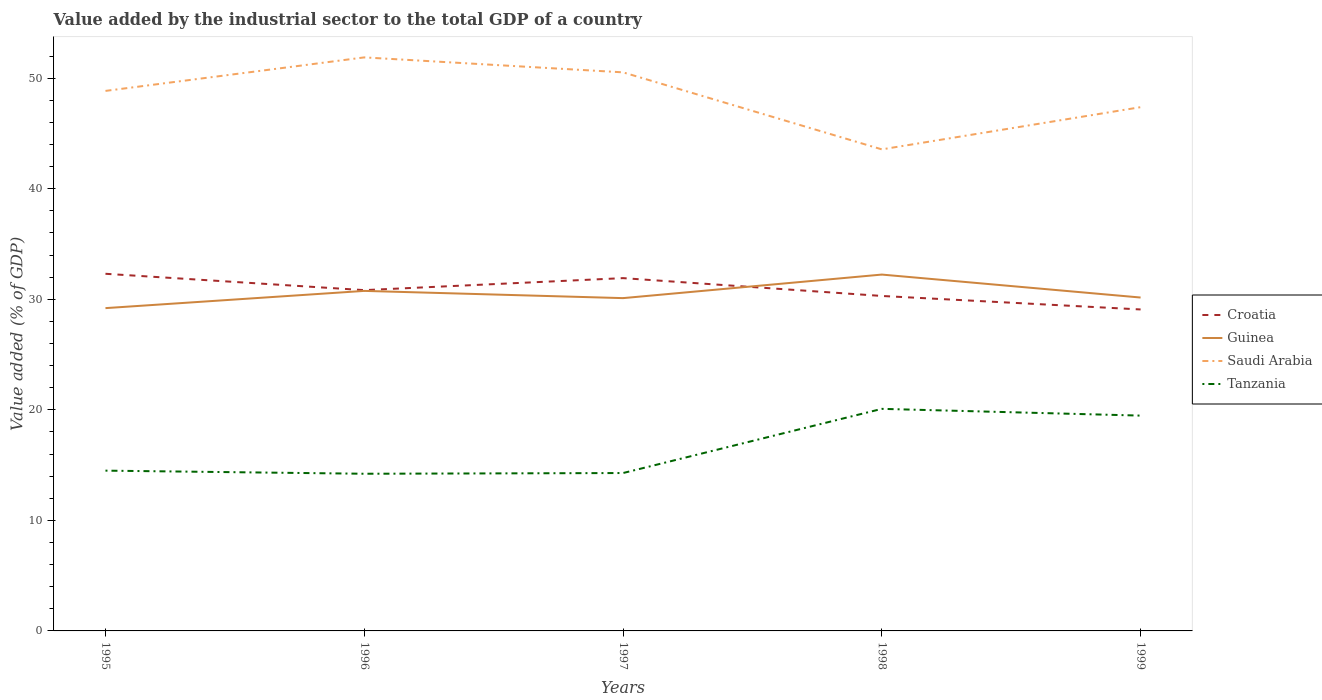Across all years, what is the maximum value added by the industrial sector to the total GDP in Saudi Arabia?
Make the answer very short. 43.56. What is the total value added by the industrial sector to the total GDP in Saudi Arabia in the graph?
Your answer should be very brief. 8.32. What is the difference between the highest and the second highest value added by the industrial sector to the total GDP in Saudi Arabia?
Ensure brevity in your answer.  8.32. What is the difference between the highest and the lowest value added by the industrial sector to the total GDP in Tanzania?
Offer a very short reply. 2. How many years are there in the graph?
Your answer should be compact. 5. What is the difference between two consecutive major ticks on the Y-axis?
Offer a very short reply. 10. Does the graph contain grids?
Make the answer very short. No. How many legend labels are there?
Keep it short and to the point. 4. How are the legend labels stacked?
Keep it short and to the point. Vertical. What is the title of the graph?
Offer a very short reply. Value added by the industrial sector to the total GDP of a country. What is the label or title of the X-axis?
Your response must be concise. Years. What is the label or title of the Y-axis?
Provide a succinct answer. Value added (% of GDP). What is the Value added (% of GDP) in Croatia in 1995?
Provide a succinct answer. 32.31. What is the Value added (% of GDP) of Guinea in 1995?
Your response must be concise. 29.2. What is the Value added (% of GDP) in Saudi Arabia in 1995?
Your response must be concise. 48.85. What is the Value added (% of GDP) in Tanzania in 1995?
Your answer should be compact. 14.5. What is the Value added (% of GDP) in Croatia in 1996?
Offer a very short reply. 30.83. What is the Value added (% of GDP) of Guinea in 1996?
Your response must be concise. 30.76. What is the Value added (% of GDP) of Saudi Arabia in 1996?
Offer a very short reply. 51.88. What is the Value added (% of GDP) in Tanzania in 1996?
Make the answer very short. 14.22. What is the Value added (% of GDP) in Croatia in 1997?
Your answer should be very brief. 31.91. What is the Value added (% of GDP) of Guinea in 1997?
Your answer should be compact. 30.11. What is the Value added (% of GDP) in Saudi Arabia in 1997?
Your answer should be very brief. 50.53. What is the Value added (% of GDP) of Tanzania in 1997?
Give a very brief answer. 14.28. What is the Value added (% of GDP) in Croatia in 1998?
Provide a succinct answer. 30.3. What is the Value added (% of GDP) of Guinea in 1998?
Provide a short and direct response. 32.24. What is the Value added (% of GDP) of Saudi Arabia in 1998?
Provide a short and direct response. 43.56. What is the Value added (% of GDP) in Tanzania in 1998?
Make the answer very short. 20.09. What is the Value added (% of GDP) of Croatia in 1999?
Your answer should be compact. 29.08. What is the Value added (% of GDP) of Guinea in 1999?
Offer a terse response. 30.16. What is the Value added (% of GDP) of Saudi Arabia in 1999?
Offer a very short reply. 47.38. What is the Value added (% of GDP) of Tanzania in 1999?
Provide a succinct answer. 19.48. Across all years, what is the maximum Value added (% of GDP) in Croatia?
Offer a terse response. 32.31. Across all years, what is the maximum Value added (% of GDP) of Guinea?
Provide a succinct answer. 32.24. Across all years, what is the maximum Value added (% of GDP) in Saudi Arabia?
Give a very brief answer. 51.88. Across all years, what is the maximum Value added (% of GDP) in Tanzania?
Make the answer very short. 20.09. Across all years, what is the minimum Value added (% of GDP) in Croatia?
Your response must be concise. 29.08. Across all years, what is the minimum Value added (% of GDP) of Guinea?
Provide a short and direct response. 29.2. Across all years, what is the minimum Value added (% of GDP) in Saudi Arabia?
Offer a very short reply. 43.56. Across all years, what is the minimum Value added (% of GDP) in Tanzania?
Provide a short and direct response. 14.22. What is the total Value added (% of GDP) of Croatia in the graph?
Make the answer very short. 154.43. What is the total Value added (% of GDP) in Guinea in the graph?
Ensure brevity in your answer.  152.46. What is the total Value added (% of GDP) of Saudi Arabia in the graph?
Your answer should be compact. 242.2. What is the total Value added (% of GDP) of Tanzania in the graph?
Give a very brief answer. 82.57. What is the difference between the Value added (% of GDP) in Croatia in 1995 and that in 1996?
Offer a very short reply. 1.48. What is the difference between the Value added (% of GDP) in Guinea in 1995 and that in 1996?
Your answer should be very brief. -1.56. What is the difference between the Value added (% of GDP) in Saudi Arabia in 1995 and that in 1996?
Make the answer very short. -3.03. What is the difference between the Value added (% of GDP) of Tanzania in 1995 and that in 1996?
Offer a terse response. 0.28. What is the difference between the Value added (% of GDP) in Croatia in 1995 and that in 1997?
Provide a short and direct response. 0.39. What is the difference between the Value added (% of GDP) of Guinea in 1995 and that in 1997?
Your answer should be very brief. -0.9. What is the difference between the Value added (% of GDP) in Saudi Arabia in 1995 and that in 1997?
Your response must be concise. -1.68. What is the difference between the Value added (% of GDP) in Tanzania in 1995 and that in 1997?
Offer a very short reply. 0.22. What is the difference between the Value added (% of GDP) of Croatia in 1995 and that in 1998?
Your answer should be compact. 2.01. What is the difference between the Value added (% of GDP) of Guinea in 1995 and that in 1998?
Make the answer very short. -3.04. What is the difference between the Value added (% of GDP) in Saudi Arabia in 1995 and that in 1998?
Provide a short and direct response. 5.29. What is the difference between the Value added (% of GDP) in Tanzania in 1995 and that in 1998?
Your response must be concise. -5.59. What is the difference between the Value added (% of GDP) in Croatia in 1995 and that in 1999?
Ensure brevity in your answer.  3.23. What is the difference between the Value added (% of GDP) in Guinea in 1995 and that in 1999?
Offer a terse response. -0.96. What is the difference between the Value added (% of GDP) of Saudi Arabia in 1995 and that in 1999?
Ensure brevity in your answer.  1.47. What is the difference between the Value added (% of GDP) in Tanzania in 1995 and that in 1999?
Offer a terse response. -4.98. What is the difference between the Value added (% of GDP) of Croatia in 1996 and that in 1997?
Keep it short and to the point. -1.09. What is the difference between the Value added (% of GDP) of Guinea in 1996 and that in 1997?
Provide a succinct answer. 0.65. What is the difference between the Value added (% of GDP) in Saudi Arabia in 1996 and that in 1997?
Your answer should be very brief. 1.35. What is the difference between the Value added (% of GDP) of Tanzania in 1996 and that in 1997?
Offer a terse response. -0.06. What is the difference between the Value added (% of GDP) in Croatia in 1996 and that in 1998?
Offer a very short reply. 0.53. What is the difference between the Value added (% of GDP) in Guinea in 1996 and that in 1998?
Provide a short and direct response. -1.48. What is the difference between the Value added (% of GDP) of Saudi Arabia in 1996 and that in 1998?
Make the answer very short. 8.32. What is the difference between the Value added (% of GDP) in Tanzania in 1996 and that in 1998?
Give a very brief answer. -5.87. What is the difference between the Value added (% of GDP) in Croatia in 1996 and that in 1999?
Provide a short and direct response. 1.75. What is the difference between the Value added (% of GDP) in Guinea in 1996 and that in 1999?
Offer a very short reply. 0.6. What is the difference between the Value added (% of GDP) of Saudi Arabia in 1996 and that in 1999?
Your response must be concise. 4.5. What is the difference between the Value added (% of GDP) of Tanzania in 1996 and that in 1999?
Provide a short and direct response. -5.26. What is the difference between the Value added (% of GDP) in Croatia in 1997 and that in 1998?
Your answer should be compact. 1.61. What is the difference between the Value added (% of GDP) in Guinea in 1997 and that in 1998?
Keep it short and to the point. -2.13. What is the difference between the Value added (% of GDP) of Saudi Arabia in 1997 and that in 1998?
Your answer should be compact. 6.97. What is the difference between the Value added (% of GDP) of Tanzania in 1997 and that in 1998?
Ensure brevity in your answer.  -5.81. What is the difference between the Value added (% of GDP) of Croatia in 1997 and that in 1999?
Make the answer very short. 2.83. What is the difference between the Value added (% of GDP) of Guinea in 1997 and that in 1999?
Offer a terse response. -0.05. What is the difference between the Value added (% of GDP) of Saudi Arabia in 1997 and that in 1999?
Provide a short and direct response. 3.15. What is the difference between the Value added (% of GDP) in Tanzania in 1997 and that in 1999?
Offer a very short reply. -5.2. What is the difference between the Value added (% of GDP) of Croatia in 1998 and that in 1999?
Ensure brevity in your answer.  1.22. What is the difference between the Value added (% of GDP) of Guinea in 1998 and that in 1999?
Offer a very short reply. 2.08. What is the difference between the Value added (% of GDP) of Saudi Arabia in 1998 and that in 1999?
Your answer should be compact. -3.82. What is the difference between the Value added (% of GDP) in Tanzania in 1998 and that in 1999?
Ensure brevity in your answer.  0.61. What is the difference between the Value added (% of GDP) of Croatia in 1995 and the Value added (% of GDP) of Guinea in 1996?
Offer a terse response. 1.55. What is the difference between the Value added (% of GDP) in Croatia in 1995 and the Value added (% of GDP) in Saudi Arabia in 1996?
Your answer should be compact. -19.58. What is the difference between the Value added (% of GDP) in Croatia in 1995 and the Value added (% of GDP) in Tanzania in 1996?
Your response must be concise. 18.09. What is the difference between the Value added (% of GDP) in Guinea in 1995 and the Value added (% of GDP) in Saudi Arabia in 1996?
Your answer should be compact. -22.68. What is the difference between the Value added (% of GDP) in Guinea in 1995 and the Value added (% of GDP) in Tanzania in 1996?
Offer a very short reply. 14.98. What is the difference between the Value added (% of GDP) in Saudi Arabia in 1995 and the Value added (% of GDP) in Tanzania in 1996?
Keep it short and to the point. 34.63. What is the difference between the Value added (% of GDP) of Croatia in 1995 and the Value added (% of GDP) of Guinea in 1997?
Your answer should be compact. 2.2. What is the difference between the Value added (% of GDP) of Croatia in 1995 and the Value added (% of GDP) of Saudi Arabia in 1997?
Your answer should be very brief. -18.22. What is the difference between the Value added (% of GDP) of Croatia in 1995 and the Value added (% of GDP) of Tanzania in 1997?
Your answer should be compact. 18.03. What is the difference between the Value added (% of GDP) in Guinea in 1995 and the Value added (% of GDP) in Saudi Arabia in 1997?
Give a very brief answer. -21.33. What is the difference between the Value added (% of GDP) in Guinea in 1995 and the Value added (% of GDP) in Tanzania in 1997?
Provide a short and direct response. 14.92. What is the difference between the Value added (% of GDP) in Saudi Arabia in 1995 and the Value added (% of GDP) in Tanzania in 1997?
Provide a short and direct response. 34.57. What is the difference between the Value added (% of GDP) of Croatia in 1995 and the Value added (% of GDP) of Guinea in 1998?
Your answer should be compact. 0.07. What is the difference between the Value added (% of GDP) in Croatia in 1995 and the Value added (% of GDP) in Saudi Arabia in 1998?
Provide a succinct answer. -11.26. What is the difference between the Value added (% of GDP) of Croatia in 1995 and the Value added (% of GDP) of Tanzania in 1998?
Offer a terse response. 12.22. What is the difference between the Value added (% of GDP) in Guinea in 1995 and the Value added (% of GDP) in Saudi Arabia in 1998?
Offer a terse response. -14.36. What is the difference between the Value added (% of GDP) in Guinea in 1995 and the Value added (% of GDP) in Tanzania in 1998?
Keep it short and to the point. 9.11. What is the difference between the Value added (% of GDP) of Saudi Arabia in 1995 and the Value added (% of GDP) of Tanzania in 1998?
Your answer should be very brief. 28.76. What is the difference between the Value added (% of GDP) of Croatia in 1995 and the Value added (% of GDP) of Guinea in 1999?
Provide a short and direct response. 2.15. What is the difference between the Value added (% of GDP) in Croatia in 1995 and the Value added (% of GDP) in Saudi Arabia in 1999?
Your answer should be very brief. -15.07. What is the difference between the Value added (% of GDP) in Croatia in 1995 and the Value added (% of GDP) in Tanzania in 1999?
Your answer should be very brief. 12.83. What is the difference between the Value added (% of GDP) of Guinea in 1995 and the Value added (% of GDP) of Saudi Arabia in 1999?
Provide a short and direct response. -18.18. What is the difference between the Value added (% of GDP) in Guinea in 1995 and the Value added (% of GDP) in Tanzania in 1999?
Make the answer very short. 9.72. What is the difference between the Value added (% of GDP) in Saudi Arabia in 1995 and the Value added (% of GDP) in Tanzania in 1999?
Make the answer very short. 29.37. What is the difference between the Value added (% of GDP) in Croatia in 1996 and the Value added (% of GDP) in Guinea in 1997?
Provide a succinct answer. 0.72. What is the difference between the Value added (% of GDP) in Croatia in 1996 and the Value added (% of GDP) in Saudi Arabia in 1997?
Your answer should be very brief. -19.7. What is the difference between the Value added (% of GDP) in Croatia in 1996 and the Value added (% of GDP) in Tanzania in 1997?
Give a very brief answer. 16.55. What is the difference between the Value added (% of GDP) of Guinea in 1996 and the Value added (% of GDP) of Saudi Arabia in 1997?
Your answer should be very brief. -19.77. What is the difference between the Value added (% of GDP) of Guinea in 1996 and the Value added (% of GDP) of Tanzania in 1997?
Make the answer very short. 16.48. What is the difference between the Value added (% of GDP) in Saudi Arabia in 1996 and the Value added (% of GDP) in Tanzania in 1997?
Keep it short and to the point. 37.6. What is the difference between the Value added (% of GDP) of Croatia in 1996 and the Value added (% of GDP) of Guinea in 1998?
Provide a short and direct response. -1.41. What is the difference between the Value added (% of GDP) of Croatia in 1996 and the Value added (% of GDP) of Saudi Arabia in 1998?
Keep it short and to the point. -12.73. What is the difference between the Value added (% of GDP) in Croatia in 1996 and the Value added (% of GDP) in Tanzania in 1998?
Your answer should be compact. 10.74. What is the difference between the Value added (% of GDP) of Guinea in 1996 and the Value added (% of GDP) of Saudi Arabia in 1998?
Make the answer very short. -12.8. What is the difference between the Value added (% of GDP) of Guinea in 1996 and the Value added (% of GDP) of Tanzania in 1998?
Offer a very short reply. 10.67. What is the difference between the Value added (% of GDP) of Saudi Arabia in 1996 and the Value added (% of GDP) of Tanzania in 1998?
Your answer should be compact. 31.79. What is the difference between the Value added (% of GDP) in Croatia in 1996 and the Value added (% of GDP) in Guinea in 1999?
Your answer should be very brief. 0.67. What is the difference between the Value added (% of GDP) of Croatia in 1996 and the Value added (% of GDP) of Saudi Arabia in 1999?
Offer a terse response. -16.55. What is the difference between the Value added (% of GDP) of Croatia in 1996 and the Value added (% of GDP) of Tanzania in 1999?
Give a very brief answer. 11.35. What is the difference between the Value added (% of GDP) of Guinea in 1996 and the Value added (% of GDP) of Saudi Arabia in 1999?
Offer a terse response. -16.62. What is the difference between the Value added (% of GDP) of Guinea in 1996 and the Value added (% of GDP) of Tanzania in 1999?
Offer a terse response. 11.28. What is the difference between the Value added (% of GDP) in Saudi Arabia in 1996 and the Value added (% of GDP) in Tanzania in 1999?
Provide a succinct answer. 32.4. What is the difference between the Value added (% of GDP) in Croatia in 1997 and the Value added (% of GDP) in Guinea in 1998?
Make the answer very short. -0.32. What is the difference between the Value added (% of GDP) of Croatia in 1997 and the Value added (% of GDP) of Saudi Arabia in 1998?
Give a very brief answer. -11.65. What is the difference between the Value added (% of GDP) of Croatia in 1997 and the Value added (% of GDP) of Tanzania in 1998?
Provide a short and direct response. 11.83. What is the difference between the Value added (% of GDP) in Guinea in 1997 and the Value added (% of GDP) in Saudi Arabia in 1998?
Give a very brief answer. -13.46. What is the difference between the Value added (% of GDP) of Guinea in 1997 and the Value added (% of GDP) of Tanzania in 1998?
Provide a succinct answer. 10.02. What is the difference between the Value added (% of GDP) in Saudi Arabia in 1997 and the Value added (% of GDP) in Tanzania in 1998?
Offer a very short reply. 30.44. What is the difference between the Value added (% of GDP) of Croatia in 1997 and the Value added (% of GDP) of Guinea in 1999?
Provide a succinct answer. 1.76. What is the difference between the Value added (% of GDP) in Croatia in 1997 and the Value added (% of GDP) in Saudi Arabia in 1999?
Offer a very short reply. -15.46. What is the difference between the Value added (% of GDP) of Croatia in 1997 and the Value added (% of GDP) of Tanzania in 1999?
Your answer should be very brief. 12.44. What is the difference between the Value added (% of GDP) of Guinea in 1997 and the Value added (% of GDP) of Saudi Arabia in 1999?
Your response must be concise. -17.27. What is the difference between the Value added (% of GDP) in Guinea in 1997 and the Value added (% of GDP) in Tanzania in 1999?
Offer a very short reply. 10.63. What is the difference between the Value added (% of GDP) in Saudi Arabia in 1997 and the Value added (% of GDP) in Tanzania in 1999?
Keep it short and to the point. 31.05. What is the difference between the Value added (% of GDP) of Croatia in 1998 and the Value added (% of GDP) of Guinea in 1999?
Provide a short and direct response. 0.14. What is the difference between the Value added (% of GDP) of Croatia in 1998 and the Value added (% of GDP) of Saudi Arabia in 1999?
Offer a terse response. -17.08. What is the difference between the Value added (% of GDP) of Croatia in 1998 and the Value added (% of GDP) of Tanzania in 1999?
Provide a short and direct response. 10.82. What is the difference between the Value added (% of GDP) of Guinea in 1998 and the Value added (% of GDP) of Saudi Arabia in 1999?
Your answer should be compact. -15.14. What is the difference between the Value added (% of GDP) in Guinea in 1998 and the Value added (% of GDP) in Tanzania in 1999?
Your response must be concise. 12.76. What is the difference between the Value added (% of GDP) of Saudi Arabia in 1998 and the Value added (% of GDP) of Tanzania in 1999?
Your response must be concise. 24.08. What is the average Value added (% of GDP) of Croatia per year?
Ensure brevity in your answer.  30.89. What is the average Value added (% of GDP) in Guinea per year?
Ensure brevity in your answer.  30.49. What is the average Value added (% of GDP) in Saudi Arabia per year?
Make the answer very short. 48.44. What is the average Value added (% of GDP) of Tanzania per year?
Ensure brevity in your answer.  16.51. In the year 1995, what is the difference between the Value added (% of GDP) in Croatia and Value added (% of GDP) in Guinea?
Your answer should be compact. 3.11. In the year 1995, what is the difference between the Value added (% of GDP) in Croatia and Value added (% of GDP) in Saudi Arabia?
Your answer should be very brief. -16.54. In the year 1995, what is the difference between the Value added (% of GDP) of Croatia and Value added (% of GDP) of Tanzania?
Provide a succinct answer. 17.81. In the year 1995, what is the difference between the Value added (% of GDP) in Guinea and Value added (% of GDP) in Saudi Arabia?
Keep it short and to the point. -19.65. In the year 1995, what is the difference between the Value added (% of GDP) in Guinea and Value added (% of GDP) in Tanzania?
Give a very brief answer. 14.7. In the year 1995, what is the difference between the Value added (% of GDP) of Saudi Arabia and Value added (% of GDP) of Tanzania?
Your answer should be compact. 34.35. In the year 1996, what is the difference between the Value added (% of GDP) of Croatia and Value added (% of GDP) of Guinea?
Make the answer very short. 0.07. In the year 1996, what is the difference between the Value added (% of GDP) in Croatia and Value added (% of GDP) in Saudi Arabia?
Your answer should be compact. -21.05. In the year 1996, what is the difference between the Value added (% of GDP) in Croatia and Value added (% of GDP) in Tanzania?
Provide a short and direct response. 16.61. In the year 1996, what is the difference between the Value added (% of GDP) of Guinea and Value added (% of GDP) of Saudi Arabia?
Ensure brevity in your answer.  -21.12. In the year 1996, what is the difference between the Value added (% of GDP) in Guinea and Value added (% of GDP) in Tanzania?
Give a very brief answer. 16.54. In the year 1996, what is the difference between the Value added (% of GDP) in Saudi Arabia and Value added (% of GDP) in Tanzania?
Ensure brevity in your answer.  37.66. In the year 1997, what is the difference between the Value added (% of GDP) in Croatia and Value added (% of GDP) in Guinea?
Your response must be concise. 1.81. In the year 1997, what is the difference between the Value added (% of GDP) in Croatia and Value added (% of GDP) in Saudi Arabia?
Your answer should be compact. -18.61. In the year 1997, what is the difference between the Value added (% of GDP) in Croatia and Value added (% of GDP) in Tanzania?
Provide a succinct answer. 17.63. In the year 1997, what is the difference between the Value added (% of GDP) in Guinea and Value added (% of GDP) in Saudi Arabia?
Give a very brief answer. -20.42. In the year 1997, what is the difference between the Value added (% of GDP) of Guinea and Value added (% of GDP) of Tanzania?
Your answer should be compact. 15.82. In the year 1997, what is the difference between the Value added (% of GDP) of Saudi Arabia and Value added (% of GDP) of Tanzania?
Give a very brief answer. 36.25. In the year 1998, what is the difference between the Value added (% of GDP) of Croatia and Value added (% of GDP) of Guinea?
Your response must be concise. -1.93. In the year 1998, what is the difference between the Value added (% of GDP) of Croatia and Value added (% of GDP) of Saudi Arabia?
Give a very brief answer. -13.26. In the year 1998, what is the difference between the Value added (% of GDP) of Croatia and Value added (% of GDP) of Tanzania?
Make the answer very short. 10.21. In the year 1998, what is the difference between the Value added (% of GDP) in Guinea and Value added (% of GDP) in Saudi Arabia?
Offer a terse response. -11.33. In the year 1998, what is the difference between the Value added (% of GDP) of Guinea and Value added (% of GDP) of Tanzania?
Ensure brevity in your answer.  12.15. In the year 1998, what is the difference between the Value added (% of GDP) in Saudi Arabia and Value added (% of GDP) in Tanzania?
Offer a very short reply. 23.47. In the year 1999, what is the difference between the Value added (% of GDP) in Croatia and Value added (% of GDP) in Guinea?
Ensure brevity in your answer.  -1.08. In the year 1999, what is the difference between the Value added (% of GDP) of Croatia and Value added (% of GDP) of Saudi Arabia?
Make the answer very short. -18.3. In the year 1999, what is the difference between the Value added (% of GDP) of Croatia and Value added (% of GDP) of Tanzania?
Keep it short and to the point. 9.6. In the year 1999, what is the difference between the Value added (% of GDP) of Guinea and Value added (% of GDP) of Saudi Arabia?
Make the answer very short. -17.22. In the year 1999, what is the difference between the Value added (% of GDP) of Guinea and Value added (% of GDP) of Tanzania?
Your answer should be compact. 10.68. In the year 1999, what is the difference between the Value added (% of GDP) of Saudi Arabia and Value added (% of GDP) of Tanzania?
Your response must be concise. 27.9. What is the ratio of the Value added (% of GDP) of Croatia in 1995 to that in 1996?
Provide a succinct answer. 1.05. What is the ratio of the Value added (% of GDP) in Guinea in 1995 to that in 1996?
Keep it short and to the point. 0.95. What is the ratio of the Value added (% of GDP) of Saudi Arabia in 1995 to that in 1996?
Ensure brevity in your answer.  0.94. What is the ratio of the Value added (% of GDP) in Tanzania in 1995 to that in 1996?
Offer a very short reply. 1.02. What is the ratio of the Value added (% of GDP) in Croatia in 1995 to that in 1997?
Your answer should be compact. 1.01. What is the ratio of the Value added (% of GDP) in Guinea in 1995 to that in 1997?
Ensure brevity in your answer.  0.97. What is the ratio of the Value added (% of GDP) of Saudi Arabia in 1995 to that in 1997?
Provide a short and direct response. 0.97. What is the ratio of the Value added (% of GDP) in Tanzania in 1995 to that in 1997?
Provide a short and direct response. 1.02. What is the ratio of the Value added (% of GDP) in Croatia in 1995 to that in 1998?
Offer a very short reply. 1.07. What is the ratio of the Value added (% of GDP) in Guinea in 1995 to that in 1998?
Give a very brief answer. 0.91. What is the ratio of the Value added (% of GDP) in Saudi Arabia in 1995 to that in 1998?
Offer a very short reply. 1.12. What is the ratio of the Value added (% of GDP) of Tanzania in 1995 to that in 1998?
Provide a short and direct response. 0.72. What is the ratio of the Value added (% of GDP) of Croatia in 1995 to that in 1999?
Offer a terse response. 1.11. What is the ratio of the Value added (% of GDP) of Guinea in 1995 to that in 1999?
Your answer should be very brief. 0.97. What is the ratio of the Value added (% of GDP) in Saudi Arabia in 1995 to that in 1999?
Keep it short and to the point. 1.03. What is the ratio of the Value added (% of GDP) of Tanzania in 1995 to that in 1999?
Provide a succinct answer. 0.74. What is the ratio of the Value added (% of GDP) of Guinea in 1996 to that in 1997?
Keep it short and to the point. 1.02. What is the ratio of the Value added (% of GDP) of Saudi Arabia in 1996 to that in 1997?
Your answer should be compact. 1.03. What is the ratio of the Value added (% of GDP) of Tanzania in 1996 to that in 1997?
Make the answer very short. 1. What is the ratio of the Value added (% of GDP) of Croatia in 1996 to that in 1998?
Make the answer very short. 1.02. What is the ratio of the Value added (% of GDP) in Guinea in 1996 to that in 1998?
Provide a succinct answer. 0.95. What is the ratio of the Value added (% of GDP) in Saudi Arabia in 1996 to that in 1998?
Keep it short and to the point. 1.19. What is the ratio of the Value added (% of GDP) of Tanzania in 1996 to that in 1998?
Keep it short and to the point. 0.71. What is the ratio of the Value added (% of GDP) of Croatia in 1996 to that in 1999?
Offer a very short reply. 1.06. What is the ratio of the Value added (% of GDP) of Guinea in 1996 to that in 1999?
Your answer should be compact. 1.02. What is the ratio of the Value added (% of GDP) in Saudi Arabia in 1996 to that in 1999?
Make the answer very short. 1.09. What is the ratio of the Value added (% of GDP) in Tanzania in 1996 to that in 1999?
Offer a terse response. 0.73. What is the ratio of the Value added (% of GDP) of Croatia in 1997 to that in 1998?
Offer a terse response. 1.05. What is the ratio of the Value added (% of GDP) in Guinea in 1997 to that in 1998?
Your answer should be very brief. 0.93. What is the ratio of the Value added (% of GDP) in Saudi Arabia in 1997 to that in 1998?
Your answer should be compact. 1.16. What is the ratio of the Value added (% of GDP) of Tanzania in 1997 to that in 1998?
Offer a very short reply. 0.71. What is the ratio of the Value added (% of GDP) of Croatia in 1997 to that in 1999?
Provide a succinct answer. 1.1. What is the ratio of the Value added (% of GDP) of Guinea in 1997 to that in 1999?
Provide a short and direct response. 1. What is the ratio of the Value added (% of GDP) of Saudi Arabia in 1997 to that in 1999?
Your answer should be very brief. 1.07. What is the ratio of the Value added (% of GDP) in Tanzania in 1997 to that in 1999?
Keep it short and to the point. 0.73. What is the ratio of the Value added (% of GDP) of Croatia in 1998 to that in 1999?
Provide a short and direct response. 1.04. What is the ratio of the Value added (% of GDP) in Guinea in 1998 to that in 1999?
Your answer should be compact. 1.07. What is the ratio of the Value added (% of GDP) in Saudi Arabia in 1998 to that in 1999?
Your answer should be very brief. 0.92. What is the ratio of the Value added (% of GDP) of Tanzania in 1998 to that in 1999?
Offer a very short reply. 1.03. What is the difference between the highest and the second highest Value added (% of GDP) in Croatia?
Give a very brief answer. 0.39. What is the difference between the highest and the second highest Value added (% of GDP) of Guinea?
Your answer should be compact. 1.48. What is the difference between the highest and the second highest Value added (% of GDP) of Saudi Arabia?
Offer a very short reply. 1.35. What is the difference between the highest and the second highest Value added (% of GDP) of Tanzania?
Keep it short and to the point. 0.61. What is the difference between the highest and the lowest Value added (% of GDP) in Croatia?
Your answer should be very brief. 3.23. What is the difference between the highest and the lowest Value added (% of GDP) of Guinea?
Keep it short and to the point. 3.04. What is the difference between the highest and the lowest Value added (% of GDP) in Saudi Arabia?
Give a very brief answer. 8.32. What is the difference between the highest and the lowest Value added (% of GDP) of Tanzania?
Provide a succinct answer. 5.87. 